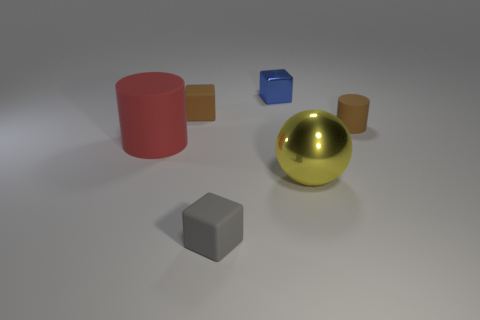What could the spatial arrangement of these objects signify in an abstract piece of art? The spatial arrangement could symbolize balance and harmony among diverse elements, or it might represent a solar system with the golden sphere as the sun and the other objects as planets, each with its own orbit and path. 